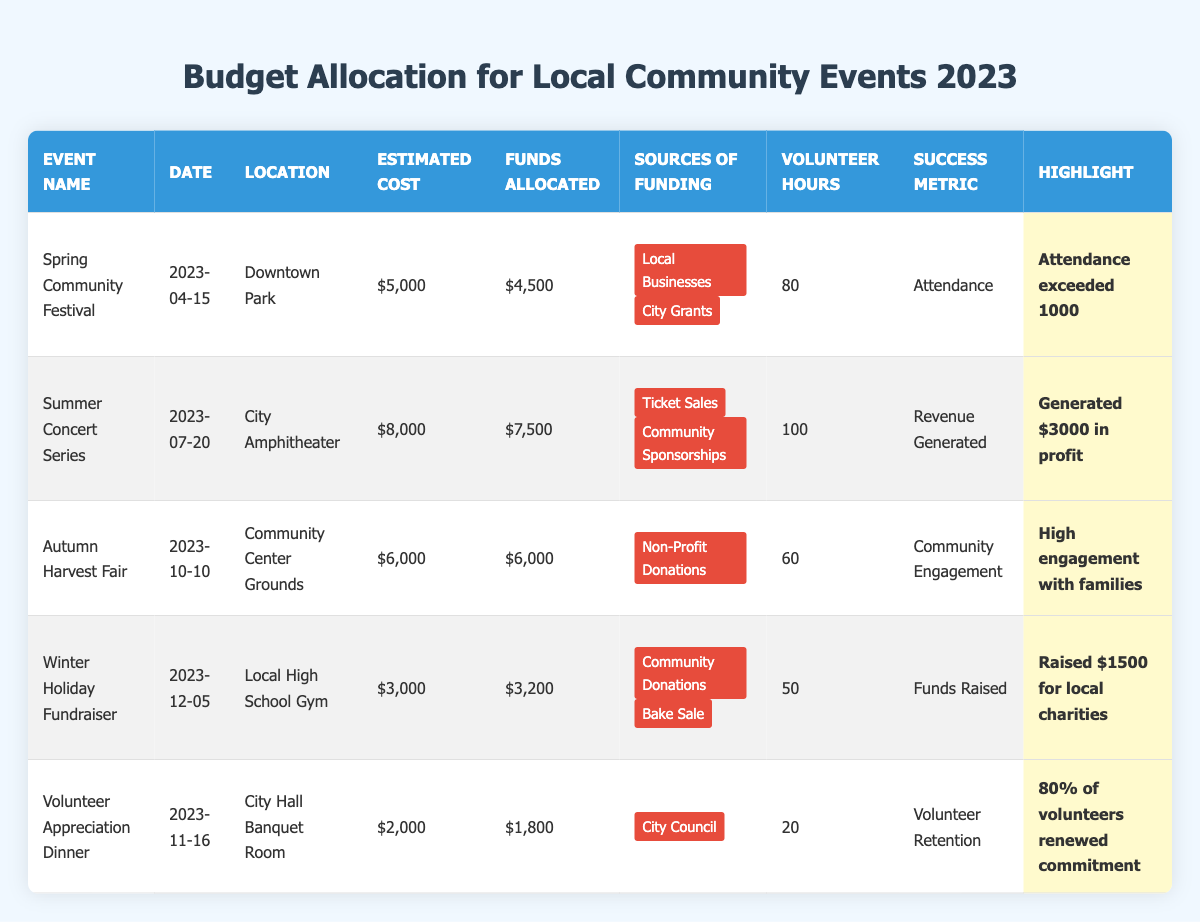What is the estimated cost of the Winter Holiday Fundraiser? The table shows that the estimated cost for the Winter Holiday Fundraiser is listed under the "Estimated Cost" column. It is stated as $3,000.
Answer: $3,000 How many volunteer hours were dedicated to the Summer Concert Series? By referring to the "Volunteer Hours" column for the Summer Concert Series, it shows that there were 100 volunteer hours allocated for this event.
Answer: 100 Which event generated the highest profit? To determine profitability, we look at the revenue information: the Summer Concert Series generated a profit of $3,000, which is stated in the "Highlight" column, while the Winter Holiday Fundraiser raised $1,500 for charities. Compared to the other events, the Summer Concert Series produced the highest financial gain.
Answer: Summer Concert Series What was the total funds allocated across all events? To find the total funds allocated, we need to sum the "Funds Allocated" amounts: $4,500 (Spring Festival) + $7,500 (Summer Concert) + $6,000 (Autumn Fair) + $3,200 (Winter Fundraiser) + $1,800 (Volunteer Dinner) = $23,000.
Answer: $23,000 Did the Autumn Harvest Fair meet its estimated cost? The Autumn Harvest Fair’s estimated cost was $6,000, and it received exactly $6,000 in funds allocated. This means it did meet its estimated cost as the allocated funds matched the estimate.
Answer: Yes Which event had the lowest number of volunteer hours and how many hours? Looking at the "Volunteer Hours" column, the event with the least hours is the Volunteer Appreciation Dinner, which had 20 volunteer hours dedicated to it.
Answer: 20 hours How does the attendance at the Spring Community Festival compare to the success metrics of the other events? The Spring Community Festival's success metric was based on attendance, which exceeded 1000 people. For other events, different metrics were used, such as revenue generated for the Summer Concert Series and community engagement for the Autumn Harvest Fair. This shows that the Spring Community Festival's attendance was evaluated differently compared to the profit or engagement metrics of other events.
Answer: Attendance was evaluated differently; 1000+ attendees is a higher metric compared to financial or engagement metrics What sources of funding were used for the Winter Holiday Fundraiser? The table states that the sources of funding for the Winter Holiday Fundraiser were "Community Donations" and "Bake Sale," as indicated in the "Sources of Funding" column.
Answer: Community Donations and Bake Sale How many events were focused on family engagement? The Autumn Harvest Fair specifically highlighted high engagement with families, while the other events focused on different metrics such as attendance and fundraising. Therefore, there is only one event explicitly listed as family-oriented.
Answer: 1 event What is the average estimated cost of the events? We calculate the average estimated cost by summing all estimated costs: $5,000 (Spring) + $8,000 (Summer) + $6,000 (Autumn) + $3,000 (Winter) + $2,000 (Volunteer Dinner) = $24,000. There are 5 events, so the average is $24,000 divided by 5, which equals $4,800.
Answer: $4,800 